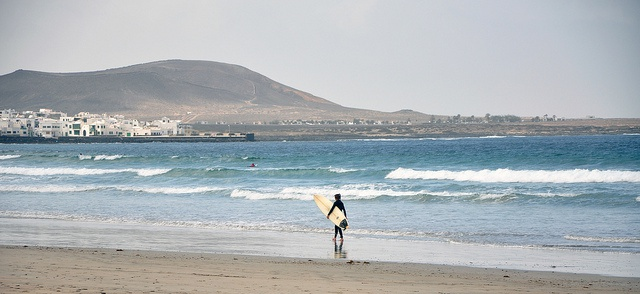Describe the objects in this image and their specific colors. I can see surfboard in darkgray, tan, beige, black, and gray tones, people in darkgray, black, gray, beige, and tan tones, and people in darkgray, purple, teal, and brown tones in this image. 